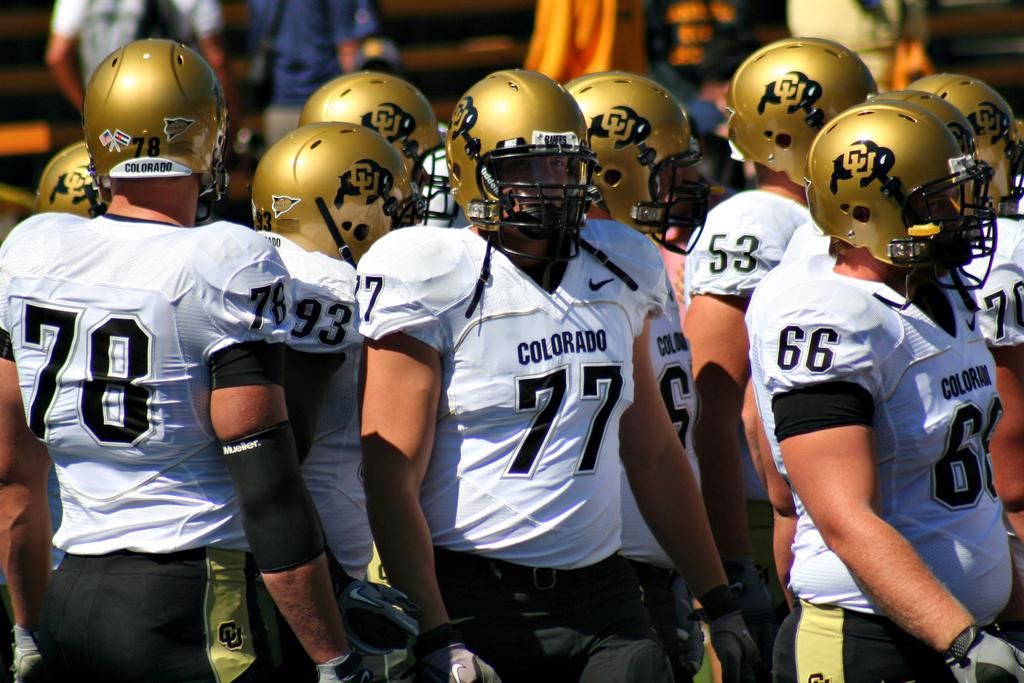What is the main subject of the image? The main subject of the image is a group of people. What are the people in the image doing? The people are standing in the image. What are the people wearing on their heads? The people are wearing helmets in the image. What color are the helmets? The helmets are gold in color. Can you describe the background of the image? The background of the image is blurred. What type of bun can be seen in the image? There is no bun present in the image. Can you tell me how many cows are visible in the image? There are no cows present in the image. 